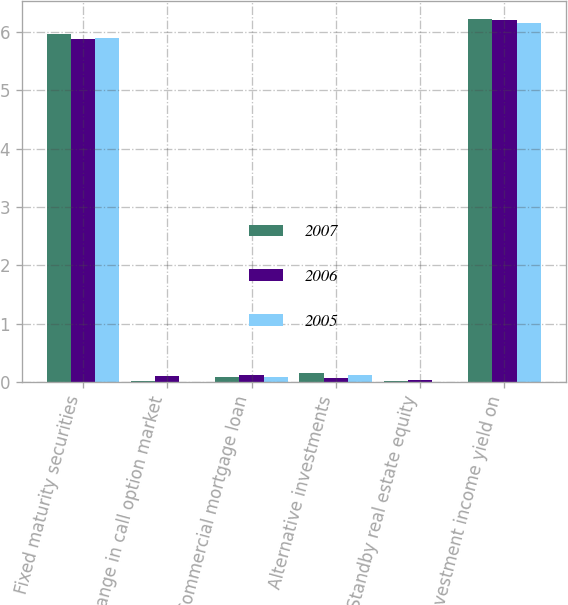Convert chart to OTSL. <chart><loc_0><loc_0><loc_500><loc_500><stacked_bar_chart><ecel><fcel>Fixed maturity securities<fcel>Change in call option market<fcel>Commercial mortgage loan<fcel>Alternative investments<fcel>Standby real estate equity<fcel>et investment income yield on<nl><fcel>2007<fcel>5.96<fcel>0.01<fcel>0.08<fcel>0.15<fcel>0.02<fcel>6.23<nl><fcel>2006<fcel>5.89<fcel>0.1<fcel>0.11<fcel>0.07<fcel>0.03<fcel>6.21<nl><fcel>2005<fcel>5.9<fcel>0<fcel>0.08<fcel>0.11<fcel>0<fcel>6.15<nl></chart> 